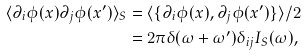Convert formula to latex. <formula><loc_0><loc_0><loc_500><loc_500>\langle \partial _ { i } \phi ( x ) \partial _ { j } \phi ( x ^ { \prime } ) \rangle _ { S } & = \langle \{ \partial _ { i } \phi ( x ) , \partial _ { j } \phi ( x ^ { \prime } ) \} \rangle / 2 \\ & = 2 \pi \delta ( \omega + \omega ^ { \prime } ) \delta _ { i j } I _ { S } ( \omega ) ,</formula> 